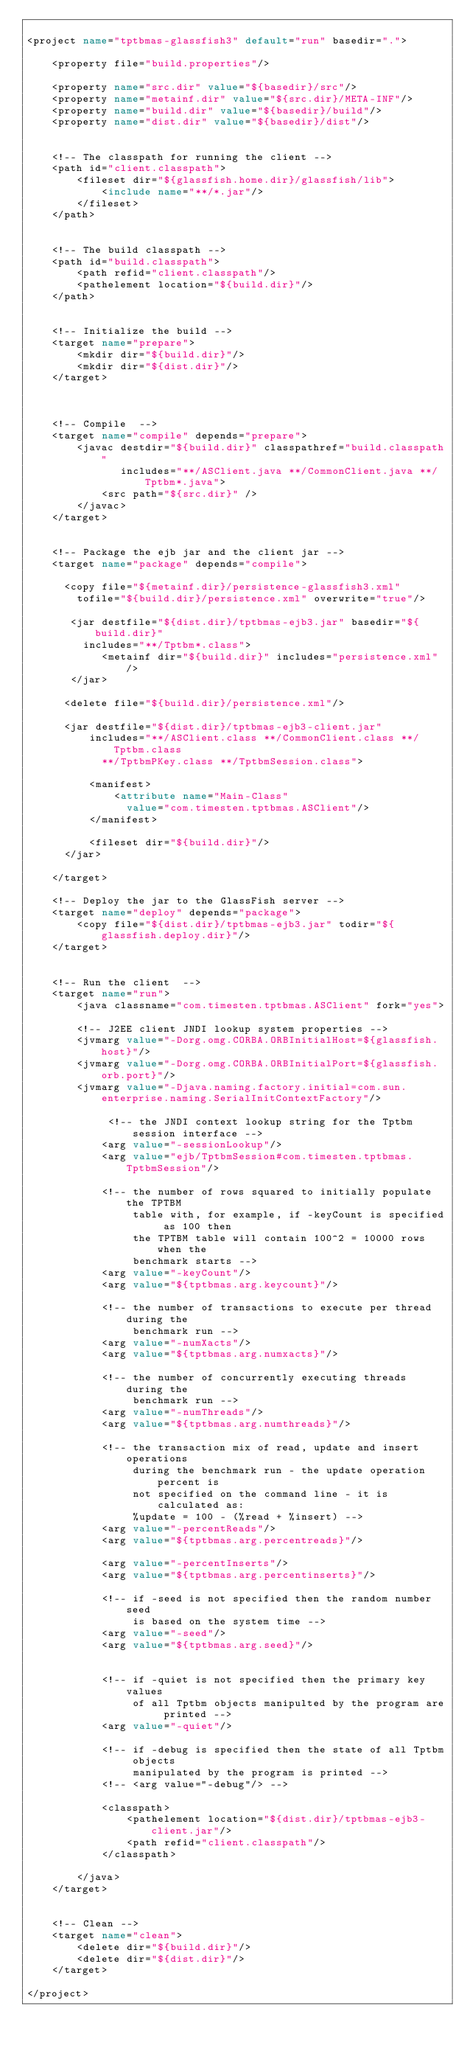Convert code to text. <code><loc_0><loc_0><loc_500><loc_500><_XML_>
<project name="tptbmas-glassfish3" default="run" basedir=".">

    <property file="build.properties"/>

    <property name="src.dir" value="${basedir}/src"/>
    <property name="metainf.dir" value="${src.dir}/META-INF"/>
    <property name="build.dir" value="${basedir}/build"/>
    <property name="dist.dir" value="${basedir}/dist"/>


    <!-- The classpath for running the client -->
    <path id="client.classpath">
        <fileset dir="${glassfish.home.dir}/glassfish/lib">
            <include name="**/*.jar"/>
        </fileset>
    </path>


    <!-- The build classpath -->
    <path id="build.classpath">
        <path refid="client.classpath"/>
        <pathelement location="${build.dir}"/>     
    </path>


    <!-- Initialize the build -->
    <target name="prepare">
        <mkdir dir="${build.dir}"/>
        <mkdir dir="${dist.dir}"/>
    </target>



    <!-- Compile  -->
    <target name="compile" depends="prepare">
        <javac destdir="${build.dir}" classpathref="build.classpath"
               includes="**/ASClient.java **/CommonClient.java **/Tptbm*.java">
            <src path="${src.dir}" />
        </javac>
    </target>
    
    
    <!-- Package the ejb jar and the client jar -->
    <target name="package" depends="compile">
    
      <copy file="${metainf.dir}/persistence-glassfish3.xml" 
        tofile="${build.dir}/persistence.xml" overwrite="true"/>  
       
       <jar destfile="${dist.dir}/tptbmas-ejb3.jar" basedir="${build.dir}"
         includes="**/Tptbm*.class">
            <metainf dir="${build.dir}" includes="persistence.xml"/>
       </jar>
              
      <delete file="${build.dir}/persistence.xml"/>      
      
      <jar destfile="${dist.dir}/tptbmas-ejb3-client.jar"
          includes="**/ASClient.class **/CommonClient.class **/Tptbm.class 
            **/TptbmPKey.class **/TptbmSession.class">
          
          <manifest>
              <attribute name="Main-Class" 
                value="com.timesten.tptbmas.ASClient"/>
          </manifest>

          <fileset dir="${build.dir}"/>
      </jar>

    </target>
    
    <!-- Deploy the jar to the GlassFish server -->
    <target name="deploy" depends="package">
        <copy file="${dist.dir}/tptbmas-ejb3.jar" todir="${glassfish.deploy.dir}"/>
    </target>


    <!-- Run the client  -->
    <target name="run">
        <java classname="com.timesten.tptbmas.ASClient" fork="yes">
        
        <!-- J2EE client JNDI lookup system properties -->
        <jvmarg value="-Dorg.omg.CORBA.ORBInitialHost=${glassfish.host}"/>
        <jvmarg value="-Dorg.omg.CORBA.ORBInitialPort=${glassfish.orb.port}"/> 
        <jvmarg value="-Djava.naming.factory.initial=com.sun.enterprise.naming.SerialInitContextFactory"/>   

             <!-- the JNDI context lookup string for the Tptbm session interface -->
            <arg value="-sessionLookup"/>
            <arg value="ejb/TptbmSession#com.timesten.tptbmas.TptbmSession"/>

            <!-- the number of rows squared to initially populate the TPTBM
                 table with, for example, if -keyCount is specified as 100 then
                 the TPTBM table will contain 100^2 = 10000 rows when the
                 benchmark starts -->
            <arg value="-keyCount"/>
            <arg value="${tptbmas.arg.keycount}"/>

            <!-- the number of transactions to execute per thread during the
                 benchmark run -->
            <arg value="-numXacts"/>
            <arg value="${tptbmas.arg.numxacts}"/>

            <!-- the number of concurrently executing threads during the
                 benchmark run -->
            <arg value="-numThreads"/>
            <arg value="${tptbmas.arg.numthreads}"/>

            <!-- the transaction mix of read, update and insert operations
                 during the benchmark run - the update operation percent is
                 not specified on the command line - it is calculated as:
                 %update = 100 - (%read + %insert) -->
            <arg value="-percentReads"/>
            <arg value="${tptbmas.arg.percentreads}"/>

            <arg value="-percentInserts"/>
            <arg value="${tptbmas.arg.percentinserts}"/>

            <!-- if -seed is not specified then the random number seed
                 is based on the system time -->
            <arg value="-seed"/>
            <arg value="${tptbmas.arg.seed}"/>


            <!-- if -quiet is not specified then the primary key values
                 of all Tptbm objects manipulted by the program are printed -->
            <arg value="-quiet"/>

            <!-- if -debug is specified then the state of all Tptbm objects
                 manipulated by the program is printed -->
            <!-- <arg value="-debug"/> -->

            <classpath>
                <pathelement location="${dist.dir}/tptbmas-ejb3-client.jar"/>
                <path refid="client.classpath"/>
            </classpath>

        </java>
    </target>


    <!-- Clean -->
    <target name="clean">
        <delete dir="${build.dir}"/>
        <delete dir="${dist.dir}"/>
    </target>

</project>


</code> 